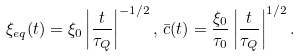Convert formula to latex. <formula><loc_0><loc_0><loc_500><loc_500>\xi _ { e q } ( t ) = \xi _ { 0 } \left | \frac { t } { \tau _ { Q } } \right | ^ { - 1 / 2 } , \, { \bar { c } } ( t ) = \frac { \xi _ { 0 } } { \tau _ { 0 } } \left | \frac { t } { \tau _ { Q } } \right | ^ { 1 / 2 } .</formula> 